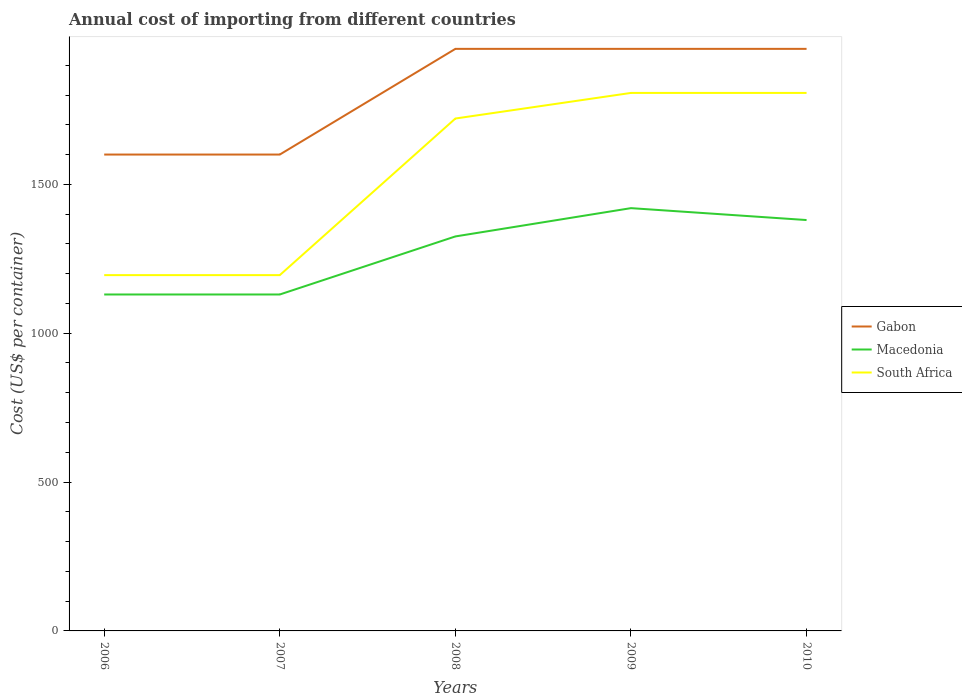How many different coloured lines are there?
Give a very brief answer. 3. Is the number of lines equal to the number of legend labels?
Ensure brevity in your answer.  Yes. Across all years, what is the maximum total annual cost of importing in Macedonia?
Give a very brief answer. 1130. What is the total total annual cost of importing in South Africa in the graph?
Your answer should be very brief. -612. What is the difference between the highest and the second highest total annual cost of importing in Macedonia?
Ensure brevity in your answer.  290. Is the total annual cost of importing in South Africa strictly greater than the total annual cost of importing in Gabon over the years?
Provide a succinct answer. Yes. How many years are there in the graph?
Your answer should be very brief. 5. Are the values on the major ticks of Y-axis written in scientific E-notation?
Ensure brevity in your answer.  No. How many legend labels are there?
Your answer should be very brief. 3. How are the legend labels stacked?
Provide a succinct answer. Vertical. What is the title of the graph?
Give a very brief answer. Annual cost of importing from different countries. Does "Hungary" appear as one of the legend labels in the graph?
Keep it short and to the point. No. What is the label or title of the X-axis?
Ensure brevity in your answer.  Years. What is the label or title of the Y-axis?
Keep it short and to the point. Cost (US$ per container). What is the Cost (US$ per container) of Gabon in 2006?
Your answer should be very brief. 1600. What is the Cost (US$ per container) of Macedonia in 2006?
Your answer should be very brief. 1130. What is the Cost (US$ per container) in South Africa in 2006?
Your response must be concise. 1195. What is the Cost (US$ per container) of Gabon in 2007?
Your answer should be very brief. 1600. What is the Cost (US$ per container) in Macedonia in 2007?
Your response must be concise. 1130. What is the Cost (US$ per container) in South Africa in 2007?
Provide a short and direct response. 1195. What is the Cost (US$ per container) of Gabon in 2008?
Your response must be concise. 1955. What is the Cost (US$ per container) of Macedonia in 2008?
Your answer should be compact. 1325. What is the Cost (US$ per container) of South Africa in 2008?
Offer a very short reply. 1721. What is the Cost (US$ per container) of Gabon in 2009?
Your answer should be very brief. 1955. What is the Cost (US$ per container) of Macedonia in 2009?
Give a very brief answer. 1420. What is the Cost (US$ per container) of South Africa in 2009?
Offer a very short reply. 1807. What is the Cost (US$ per container) of Gabon in 2010?
Make the answer very short. 1955. What is the Cost (US$ per container) in Macedonia in 2010?
Ensure brevity in your answer.  1380. What is the Cost (US$ per container) in South Africa in 2010?
Give a very brief answer. 1807. Across all years, what is the maximum Cost (US$ per container) of Gabon?
Offer a terse response. 1955. Across all years, what is the maximum Cost (US$ per container) in Macedonia?
Your response must be concise. 1420. Across all years, what is the maximum Cost (US$ per container) of South Africa?
Offer a very short reply. 1807. Across all years, what is the minimum Cost (US$ per container) of Gabon?
Provide a succinct answer. 1600. Across all years, what is the minimum Cost (US$ per container) of Macedonia?
Give a very brief answer. 1130. Across all years, what is the minimum Cost (US$ per container) of South Africa?
Offer a terse response. 1195. What is the total Cost (US$ per container) of Gabon in the graph?
Provide a succinct answer. 9065. What is the total Cost (US$ per container) of Macedonia in the graph?
Offer a very short reply. 6385. What is the total Cost (US$ per container) of South Africa in the graph?
Give a very brief answer. 7725. What is the difference between the Cost (US$ per container) of Macedonia in 2006 and that in 2007?
Make the answer very short. 0. What is the difference between the Cost (US$ per container) in Gabon in 2006 and that in 2008?
Offer a terse response. -355. What is the difference between the Cost (US$ per container) of Macedonia in 2006 and that in 2008?
Provide a succinct answer. -195. What is the difference between the Cost (US$ per container) of South Africa in 2006 and that in 2008?
Provide a short and direct response. -526. What is the difference between the Cost (US$ per container) of Gabon in 2006 and that in 2009?
Your answer should be very brief. -355. What is the difference between the Cost (US$ per container) in Macedonia in 2006 and that in 2009?
Ensure brevity in your answer.  -290. What is the difference between the Cost (US$ per container) in South Africa in 2006 and that in 2009?
Provide a short and direct response. -612. What is the difference between the Cost (US$ per container) of Gabon in 2006 and that in 2010?
Make the answer very short. -355. What is the difference between the Cost (US$ per container) in Macedonia in 2006 and that in 2010?
Your answer should be very brief. -250. What is the difference between the Cost (US$ per container) in South Africa in 2006 and that in 2010?
Offer a terse response. -612. What is the difference between the Cost (US$ per container) of Gabon in 2007 and that in 2008?
Make the answer very short. -355. What is the difference between the Cost (US$ per container) of Macedonia in 2007 and that in 2008?
Your response must be concise. -195. What is the difference between the Cost (US$ per container) in South Africa in 2007 and that in 2008?
Offer a terse response. -526. What is the difference between the Cost (US$ per container) of Gabon in 2007 and that in 2009?
Offer a very short reply. -355. What is the difference between the Cost (US$ per container) in Macedonia in 2007 and that in 2009?
Ensure brevity in your answer.  -290. What is the difference between the Cost (US$ per container) in South Africa in 2007 and that in 2009?
Make the answer very short. -612. What is the difference between the Cost (US$ per container) in Gabon in 2007 and that in 2010?
Offer a very short reply. -355. What is the difference between the Cost (US$ per container) in Macedonia in 2007 and that in 2010?
Your answer should be compact. -250. What is the difference between the Cost (US$ per container) of South Africa in 2007 and that in 2010?
Offer a terse response. -612. What is the difference between the Cost (US$ per container) of Macedonia in 2008 and that in 2009?
Make the answer very short. -95. What is the difference between the Cost (US$ per container) in South Africa in 2008 and that in 2009?
Provide a short and direct response. -86. What is the difference between the Cost (US$ per container) in Macedonia in 2008 and that in 2010?
Your answer should be very brief. -55. What is the difference between the Cost (US$ per container) in South Africa in 2008 and that in 2010?
Offer a terse response. -86. What is the difference between the Cost (US$ per container) in South Africa in 2009 and that in 2010?
Your answer should be very brief. 0. What is the difference between the Cost (US$ per container) of Gabon in 2006 and the Cost (US$ per container) of Macedonia in 2007?
Ensure brevity in your answer.  470. What is the difference between the Cost (US$ per container) in Gabon in 2006 and the Cost (US$ per container) in South Africa in 2007?
Your answer should be very brief. 405. What is the difference between the Cost (US$ per container) of Macedonia in 2006 and the Cost (US$ per container) of South Africa in 2007?
Keep it short and to the point. -65. What is the difference between the Cost (US$ per container) in Gabon in 2006 and the Cost (US$ per container) in Macedonia in 2008?
Give a very brief answer. 275. What is the difference between the Cost (US$ per container) of Gabon in 2006 and the Cost (US$ per container) of South Africa in 2008?
Ensure brevity in your answer.  -121. What is the difference between the Cost (US$ per container) in Macedonia in 2006 and the Cost (US$ per container) in South Africa in 2008?
Your response must be concise. -591. What is the difference between the Cost (US$ per container) in Gabon in 2006 and the Cost (US$ per container) in Macedonia in 2009?
Ensure brevity in your answer.  180. What is the difference between the Cost (US$ per container) in Gabon in 2006 and the Cost (US$ per container) in South Africa in 2009?
Offer a very short reply. -207. What is the difference between the Cost (US$ per container) in Macedonia in 2006 and the Cost (US$ per container) in South Africa in 2009?
Your answer should be very brief. -677. What is the difference between the Cost (US$ per container) of Gabon in 2006 and the Cost (US$ per container) of Macedonia in 2010?
Your answer should be very brief. 220. What is the difference between the Cost (US$ per container) of Gabon in 2006 and the Cost (US$ per container) of South Africa in 2010?
Offer a terse response. -207. What is the difference between the Cost (US$ per container) of Macedonia in 2006 and the Cost (US$ per container) of South Africa in 2010?
Keep it short and to the point. -677. What is the difference between the Cost (US$ per container) in Gabon in 2007 and the Cost (US$ per container) in Macedonia in 2008?
Provide a succinct answer. 275. What is the difference between the Cost (US$ per container) of Gabon in 2007 and the Cost (US$ per container) of South Africa in 2008?
Give a very brief answer. -121. What is the difference between the Cost (US$ per container) of Macedonia in 2007 and the Cost (US$ per container) of South Africa in 2008?
Your answer should be very brief. -591. What is the difference between the Cost (US$ per container) in Gabon in 2007 and the Cost (US$ per container) in Macedonia in 2009?
Offer a very short reply. 180. What is the difference between the Cost (US$ per container) of Gabon in 2007 and the Cost (US$ per container) of South Africa in 2009?
Make the answer very short. -207. What is the difference between the Cost (US$ per container) of Macedonia in 2007 and the Cost (US$ per container) of South Africa in 2009?
Ensure brevity in your answer.  -677. What is the difference between the Cost (US$ per container) in Gabon in 2007 and the Cost (US$ per container) in Macedonia in 2010?
Provide a short and direct response. 220. What is the difference between the Cost (US$ per container) of Gabon in 2007 and the Cost (US$ per container) of South Africa in 2010?
Give a very brief answer. -207. What is the difference between the Cost (US$ per container) of Macedonia in 2007 and the Cost (US$ per container) of South Africa in 2010?
Make the answer very short. -677. What is the difference between the Cost (US$ per container) of Gabon in 2008 and the Cost (US$ per container) of Macedonia in 2009?
Give a very brief answer. 535. What is the difference between the Cost (US$ per container) of Gabon in 2008 and the Cost (US$ per container) of South Africa in 2009?
Give a very brief answer. 148. What is the difference between the Cost (US$ per container) in Macedonia in 2008 and the Cost (US$ per container) in South Africa in 2009?
Keep it short and to the point. -482. What is the difference between the Cost (US$ per container) in Gabon in 2008 and the Cost (US$ per container) in Macedonia in 2010?
Provide a succinct answer. 575. What is the difference between the Cost (US$ per container) of Gabon in 2008 and the Cost (US$ per container) of South Africa in 2010?
Your answer should be very brief. 148. What is the difference between the Cost (US$ per container) in Macedonia in 2008 and the Cost (US$ per container) in South Africa in 2010?
Provide a short and direct response. -482. What is the difference between the Cost (US$ per container) in Gabon in 2009 and the Cost (US$ per container) in Macedonia in 2010?
Keep it short and to the point. 575. What is the difference between the Cost (US$ per container) in Gabon in 2009 and the Cost (US$ per container) in South Africa in 2010?
Provide a short and direct response. 148. What is the difference between the Cost (US$ per container) in Macedonia in 2009 and the Cost (US$ per container) in South Africa in 2010?
Make the answer very short. -387. What is the average Cost (US$ per container) in Gabon per year?
Your answer should be very brief. 1813. What is the average Cost (US$ per container) of Macedonia per year?
Your answer should be very brief. 1277. What is the average Cost (US$ per container) in South Africa per year?
Offer a terse response. 1545. In the year 2006, what is the difference between the Cost (US$ per container) of Gabon and Cost (US$ per container) of Macedonia?
Your response must be concise. 470. In the year 2006, what is the difference between the Cost (US$ per container) of Gabon and Cost (US$ per container) of South Africa?
Make the answer very short. 405. In the year 2006, what is the difference between the Cost (US$ per container) of Macedonia and Cost (US$ per container) of South Africa?
Your response must be concise. -65. In the year 2007, what is the difference between the Cost (US$ per container) of Gabon and Cost (US$ per container) of Macedonia?
Offer a terse response. 470. In the year 2007, what is the difference between the Cost (US$ per container) of Gabon and Cost (US$ per container) of South Africa?
Keep it short and to the point. 405. In the year 2007, what is the difference between the Cost (US$ per container) in Macedonia and Cost (US$ per container) in South Africa?
Provide a succinct answer. -65. In the year 2008, what is the difference between the Cost (US$ per container) of Gabon and Cost (US$ per container) of Macedonia?
Offer a terse response. 630. In the year 2008, what is the difference between the Cost (US$ per container) in Gabon and Cost (US$ per container) in South Africa?
Your answer should be very brief. 234. In the year 2008, what is the difference between the Cost (US$ per container) in Macedonia and Cost (US$ per container) in South Africa?
Make the answer very short. -396. In the year 2009, what is the difference between the Cost (US$ per container) of Gabon and Cost (US$ per container) of Macedonia?
Your response must be concise. 535. In the year 2009, what is the difference between the Cost (US$ per container) in Gabon and Cost (US$ per container) in South Africa?
Give a very brief answer. 148. In the year 2009, what is the difference between the Cost (US$ per container) of Macedonia and Cost (US$ per container) of South Africa?
Make the answer very short. -387. In the year 2010, what is the difference between the Cost (US$ per container) of Gabon and Cost (US$ per container) of Macedonia?
Give a very brief answer. 575. In the year 2010, what is the difference between the Cost (US$ per container) in Gabon and Cost (US$ per container) in South Africa?
Offer a terse response. 148. In the year 2010, what is the difference between the Cost (US$ per container) of Macedonia and Cost (US$ per container) of South Africa?
Your answer should be compact. -427. What is the ratio of the Cost (US$ per container) of Gabon in 2006 to that in 2007?
Ensure brevity in your answer.  1. What is the ratio of the Cost (US$ per container) in Macedonia in 2006 to that in 2007?
Make the answer very short. 1. What is the ratio of the Cost (US$ per container) of Gabon in 2006 to that in 2008?
Provide a short and direct response. 0.82. What is the ratio of the Cost (US$ per container) of Macedonia in 2006 to that in 2008?
Offer a terse response. 0.85. What is the ratio of the Cost (US$ per container) in South Africa in 2006 to that in 2008?
Give a very brief answer. 0.69. What is the ratio of the Cost (US$ per container) in Gabon in 2006 to that in 2009?
Give a very brief answer. 0.82. What is the ratio of the Cost (US$ per container) of Macedonia in 2006 to that in 2009?
Offer a terse response. 0.8. What is the ratio of the Cost (US$ per container) in South Africa in 2006 to that in 2009?
Your answer should be compact. 0.66. What is the ratio of the Cost (US$ per container) in Gabon in 2006 to that in 2010?
Make the answer very short. 0.82. What is the ratio of the Cost (US$ per container) of Macedonia in 2006 to that in 2010?
Give a very brief answer. 0.82. What is the ratio of the Cost (US$ per container) of South Africa in 2006 to that in 2010?
Your answer should be compact. 0.66. What is the ratio of the Cost (US$ per container) in Gabon in 2007 to that in 2008?
Provide a succinct answer. 0.82. What is the ratio of the Cost (US$ per container) of Macedonia in 2007 to that in 2008?
Your answer should be compact. 0.85. What is the ratio of the Cost (US$ per container) of South Africa in 2007 to that in 2008?
Offer a very short reply. 0.69. What is the ratio of the Cost (US$ per container) in Gabon in 2007 to that in 2009?
Make the answer very short. 0.82. What is the ratio of the Cost (US$ per container) in Macedonia in 2007 to that in 2009?
Your response must be concise. 0.8. What is the ratio of the Cost (US$ per container) of South Africa in 2007 to that in 2009?
Offer a terse response. 0.66. What is the ratio of the Cost (US$ per container) of Gabon in 2007 to that in 2010?
Keep it short and to the point. 0.82. What is the ratio of the Cost (US$ per container) in Macedonia in 2007 to that in 2010?
Make the answer very short. 0.82. What is the ratio of the Cost (US$ per container) in South Africa in 2007 to that in 2010?
Ensure brevity in your answer.  0.66. What is the ratio of the Cost (US$ per container) of Gabon in 2008 to that in 2009?
Your answer should be compact. 1. What is the ratio of the Cost (US$ per container) of Macedonia in 2008 to that in 2009?
Keep it short and to the point. 0.93. What is the ratio of the Cost (US$ per container) in South Africa in 2008 to that in 2009?
Your answer should be compact. 0.95. What is the ratio of the Cost (US$ per container) in Gabon in 2008 to that in 2010?
Your answer should be compact. 1. What is the ratio of the Cost (US$ per container) in Macedonia in 2008 to that in 2010?
Make the answer very short. 0.96. What is the ratio of the Cost (US$ per container) of South Africa in 2008 to that in 2010?
Ensure brevity in your answer.  0.95. What is the difference between the highest and the second highest Cost (US$ per container) of Macedonia?
Your answer should be compact. 40. What is the difference between the highest and the lowest Cost (US$ per container) in Gabon?
Provide a short and direct response. 355. What is the difference between the highest and the lowest Cost (US$ per container) in Macedonia?
Provide a succinct answer. 290. What is the difference between the highest and the lowest Cost (US$ per container) of South Africa?
Your answer should be compact. 612. 